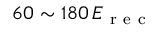Convert formula to latex. <formula><loc_0><loc_0><loc_500><loc_500>6 0 \sim 1 8 0 \, E _ { r e c }</formula> 